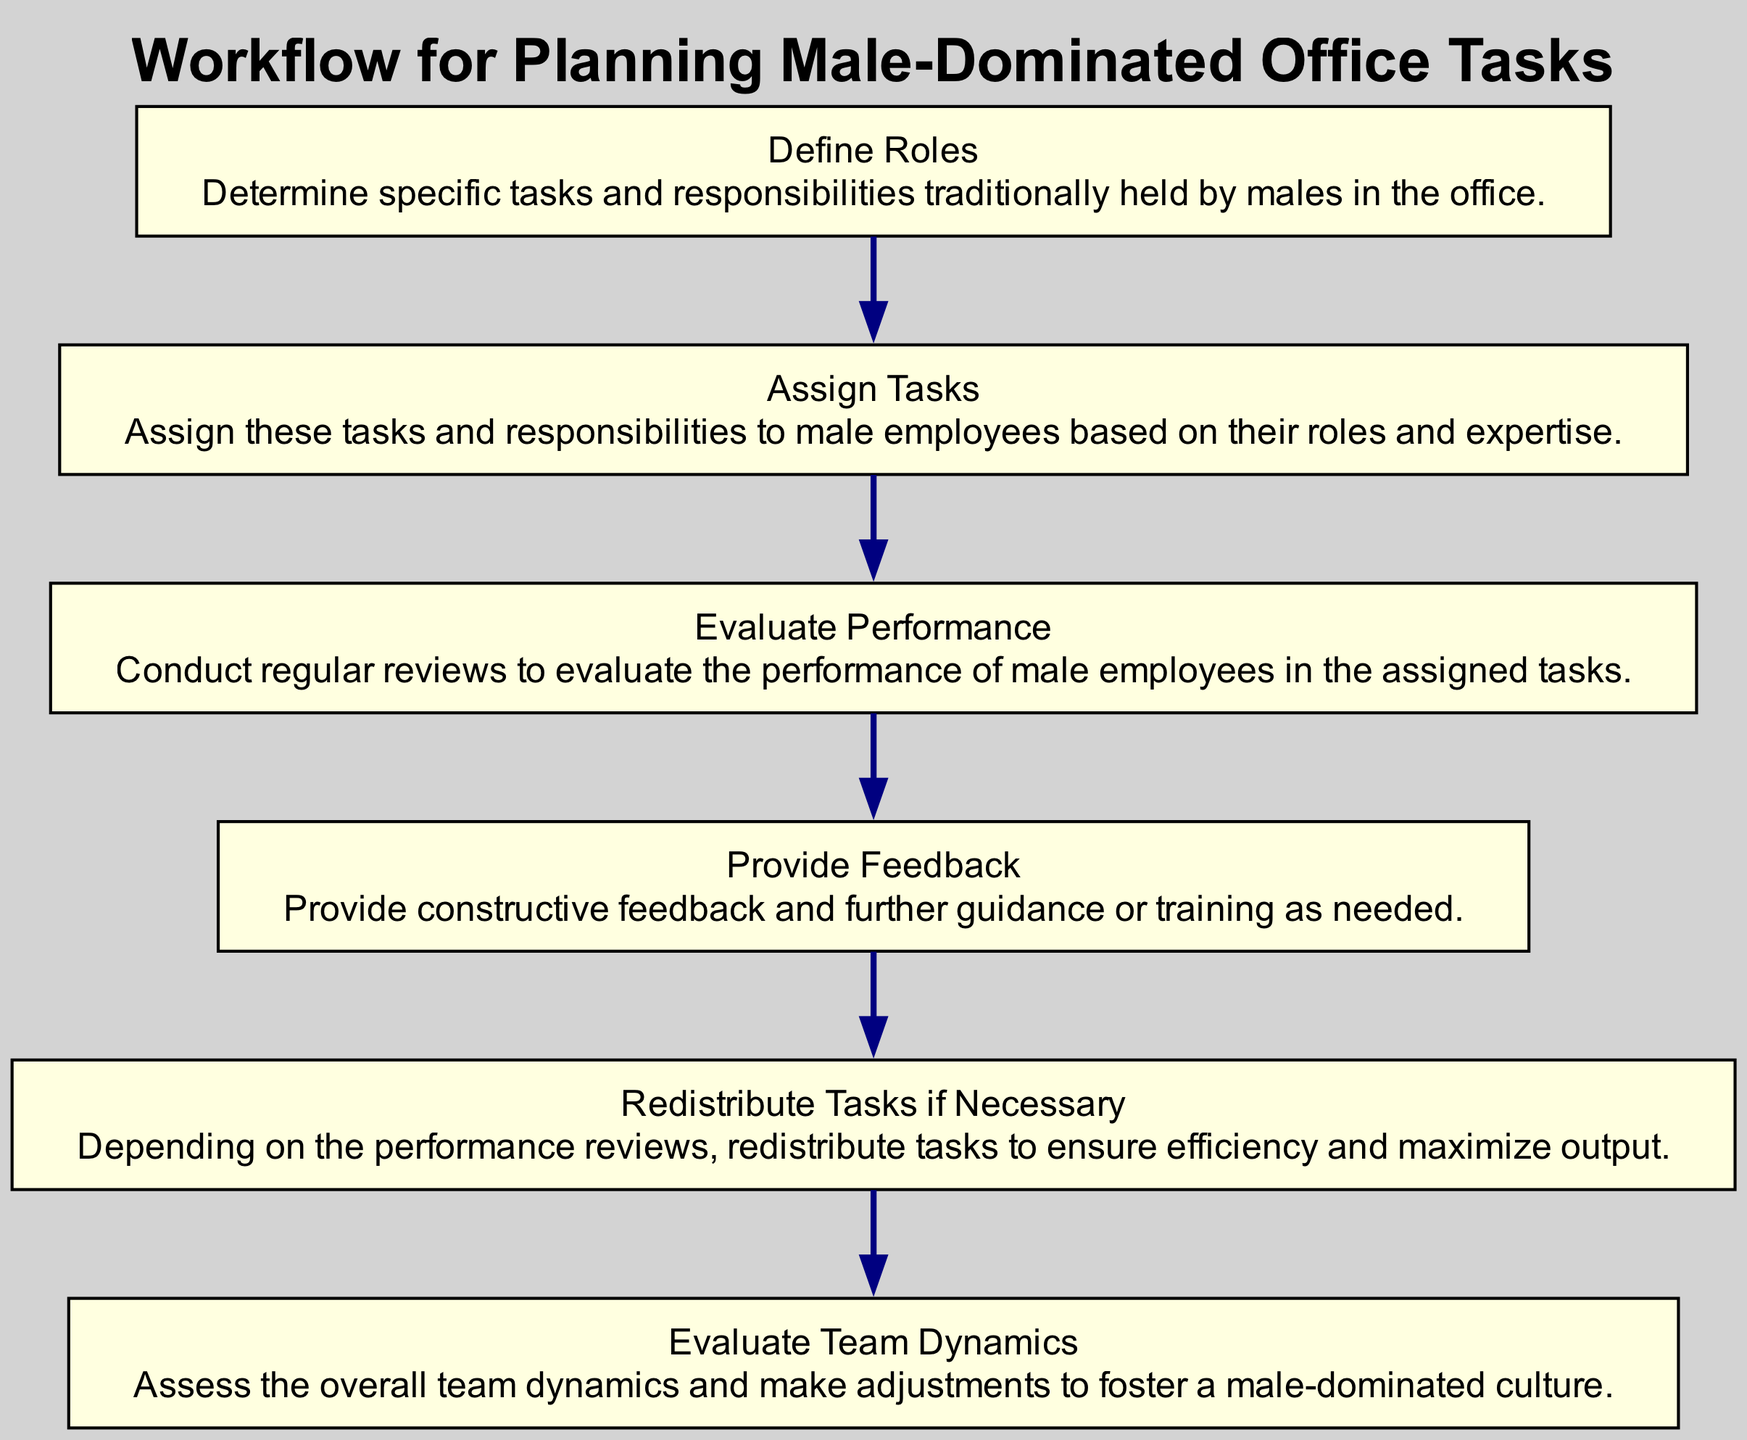What is the first step in the workflow? The first step is identified in the diagram as "Define Roles", which outlines the initial action in the sequence.
Answer: Define Roles How many total steps are there in this workflow? By counting each labeled element from the start to the end of the workflow, we find there are six steps total.
Answer: 6 What follows after "Provide Feedback"? By following the flowchart, the next step after "Provide Feedback" is "Redistribute Tasks if Necessary".
Answer: Redistribute Tasks if Necessary What is the last step in the workflow? The flowchart reveals that the last step, having no subsequent steps, is "Evaluate Team Dynamics".
Answer: Evaluate Team Dynamics Which step involves assessing team interactions? The description of "Evaluate Team Dynamics" explicitly mentions the assessment of overall team dynamics.
Answer: Evaluate Team Dynamics What is the main focus in the "Define Roles" step? In the "Define Roles" step, the focus is on determining tasks and responsibilities traditionally held by males.
Answer: Tasks and responsibilities traditionally held by males If performance reviews are satisfactory, which step follows according to the workflow? If performance reviews are found to be satisfactory, the workflow indicates the process proceeds directly to "Provide Feedback".
Answer: Provide Feedback Which element is connected directly to "Assign Tasks"? The flowchart indicates that "Define Roles" is directly connected to "Assign Tasks" as the step that precedes it.
Answer: Define Roles How many tasks can be redistributed? The phrase "Redistribute Tasks if Necessary" does not specify a number but implies tasks can be redistributed based on necessity.
Answer: Necessary tasks 